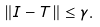Convert formula to latex. <formula><loc_0><loc_0><loc_500><loc_500>\| I - T \| \leq \gamma .</formula> 